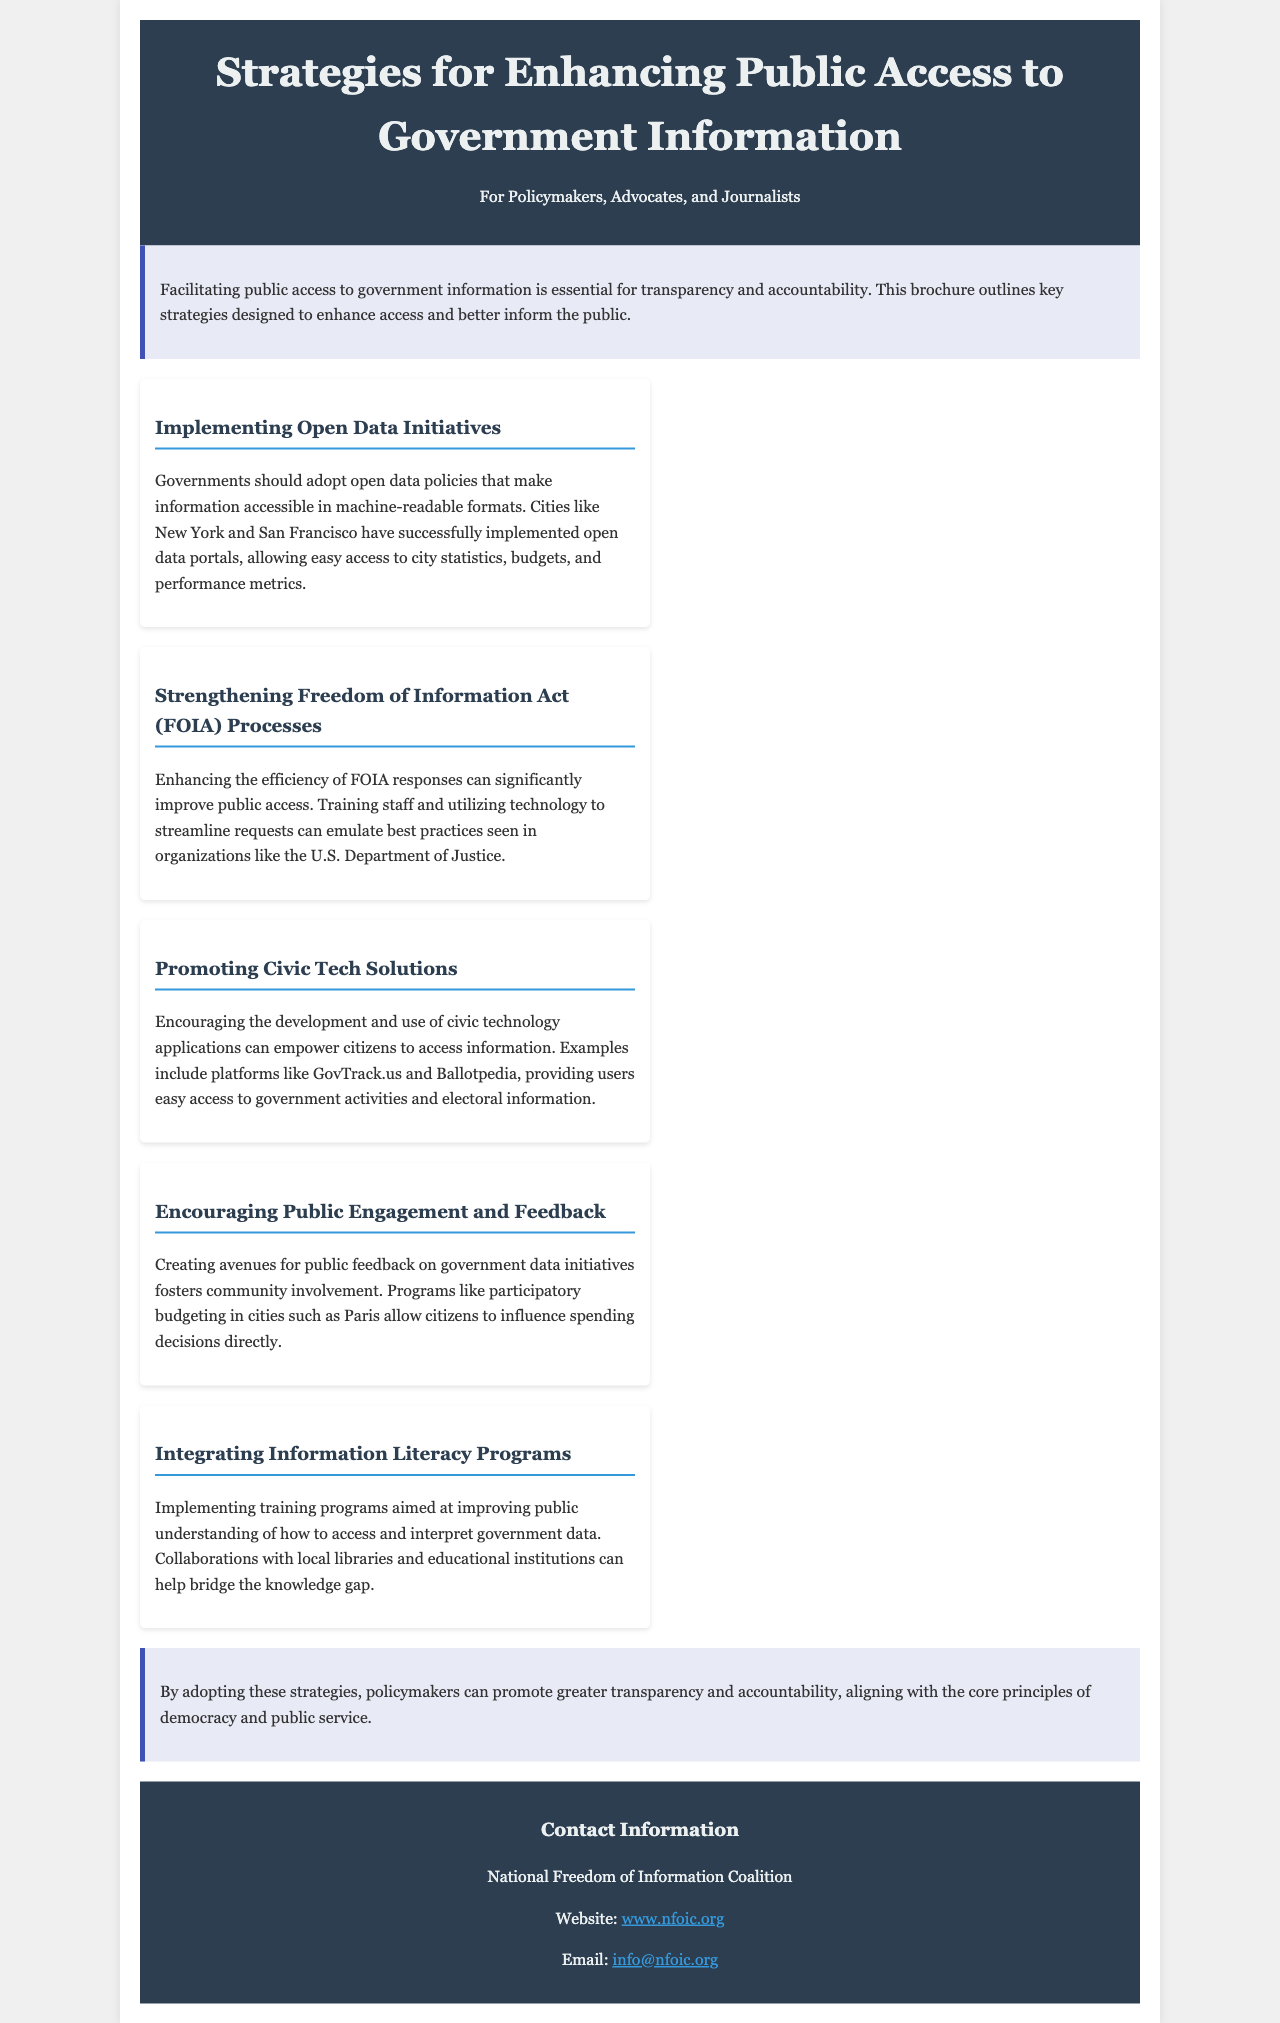What is the title of the brochure? The title of the brochure is provided in the header section of the document, stating the purpose of the content.
Answer: Strategies for Enhancing Public Access to Government Information Who is the intended audience of the brochure? The intended audience is mentioned just below the title, indicating who should read the material.
Answer: Policymakers, Advocates, and Journalists Name one city that has successfully implemented open data portals. The document lists examples of cities with successful open data initiatives.
Answer: New York What strategy involves using technology to improve FOIA responses? The need for enhancing efficiency in FOIA processes is addressed, focusing on training and technology use.
Answer: Strengthening Freedom of Information Act (FOIA) Processes What educational initiative is suggested to improve public understanding? The brochure recommends a program that specifically helps the public understand how to access and interpret data.
Answer: Integrating Information Literacy Programs Which strategy promotes community involvement in government data initiatives? The document describes a specific program that allows citizens to influence spending decisions, reflecting this concept.
Answer: Encouraging Public Engagement and Feedback What organization is listed for contact information at the end? The contact section provides the name of the organization that readers can reach out to for more information.
Answer: National Freedom of Information Coalition What is the purpose of the introduction section? The introduction outlines the overall aim of the brochure, emphasizing a specific principle critical in governance.
Answer: Transparency and accountability 